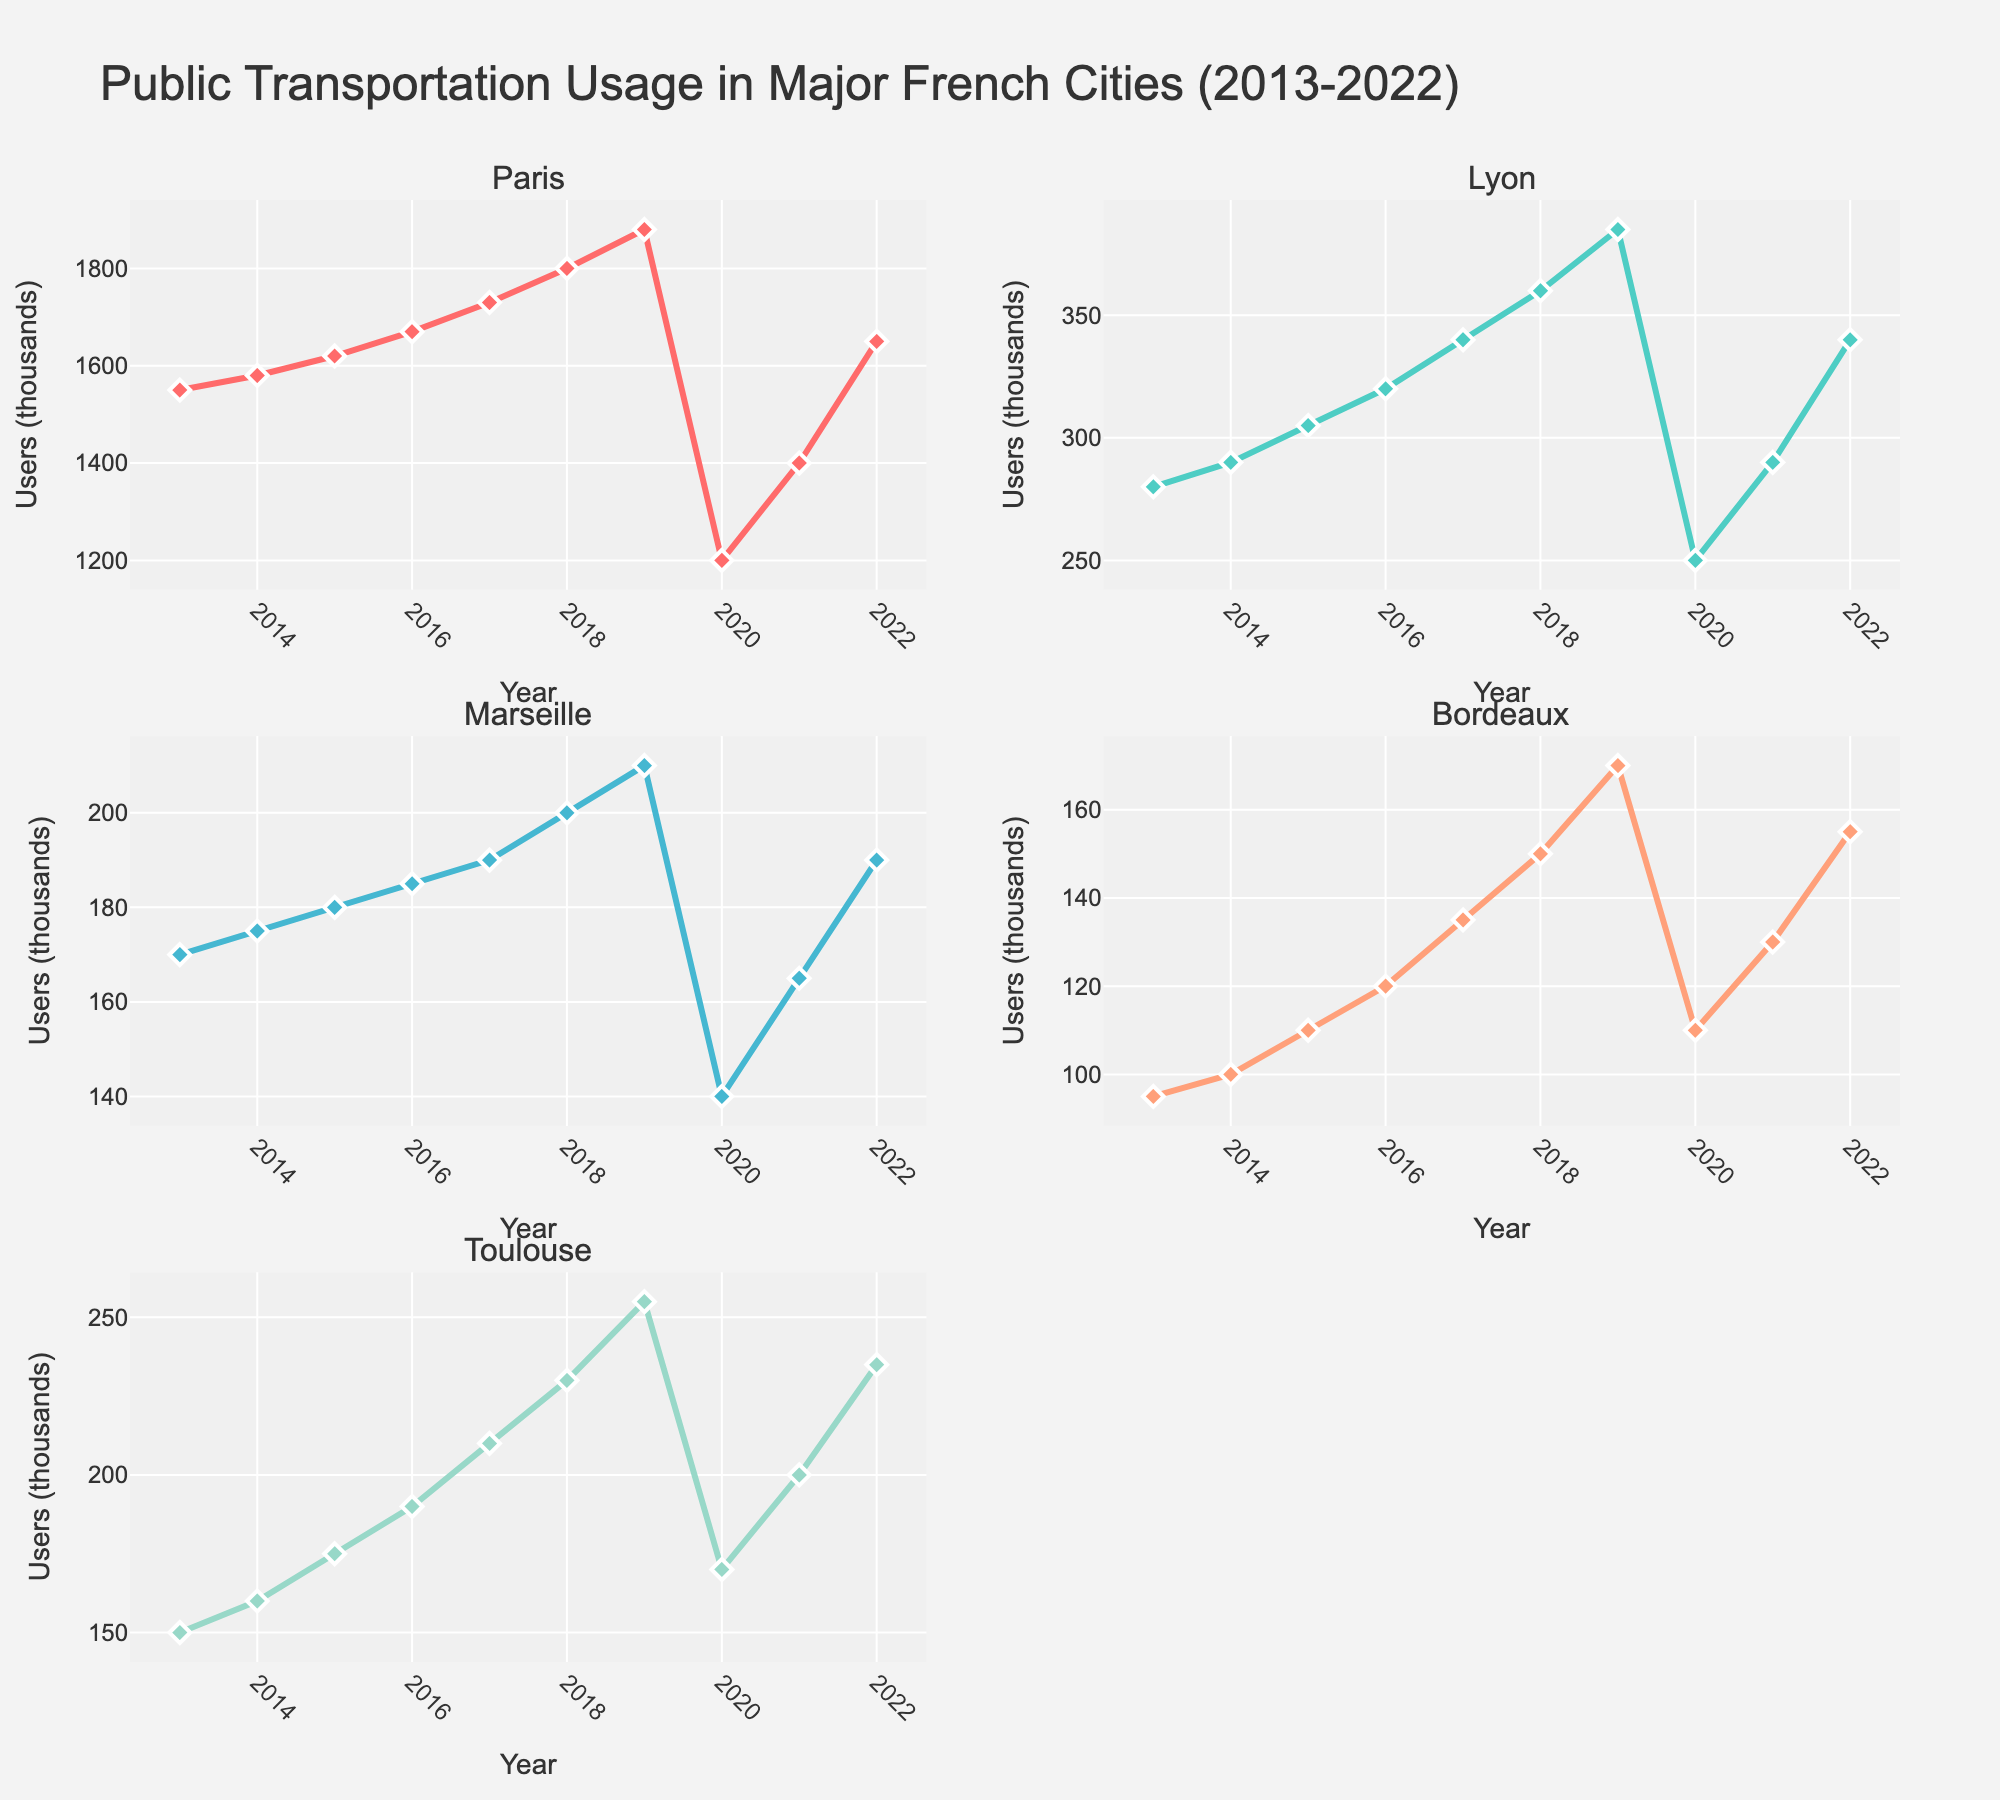What is the title of the figure? The title of the figure is usually located at the top of the plot, displaying an overall description of what the figure is about. In this case, it is "Public Transportation Usage in Major French Cities (2013-2022).”
Answer: Public Transportation Usage in Major French Cities (2013-2022) Which city had the highest public transportation usage in 2019? To find this, look at the subplot for each city and compare their values in 2019. The subplot for Paris has the highest value at 1880 thousand users.
Answer: Paris What is the trend of public transportation usage in Toulouse over the given years? Examine the subplot for Toulouse and observe the trajectory of the line from 2013 to 2022. Aside from a drop in 2020, the general trend is an increase.
Answer: Increasing In which year did Paris see the largest drop in public transportation usage? Observing the subplot for Paris, the year with the most significant drop is from 2019 to 2020, where usage fell from 1880 to 1200 thousand users.
Answer: 2020 How many users did Marseille have in 2016? Locate the subplot for Marseille and find the value corresponding to the year 2016, which is 185 thousand users.
Answer: 185 Compare the public transportation usage trends of Lyon and Marseille from 2013 to 2022. Look at both subplots for Lyon and Marseille. Lyon shows a consistent increase with a slight drop in 2020, while Marseille shows smaller but steady increments with a drop in 2020 as well.
Answer: Both increasing with a drop in 2020 What was the public transportation usage in Bordeaux in 2018? Examine the subplot for Bordeaux and find the value in 2018, which is 150 thousand users.
Answer: 150 Which city had the least public transportation usage in 2020? Check the values for each city in 2020 across the subplots. Marseille had the least usage at 140 thousand users.
Answer: Marseille How did public transportation usage change in Paris from 2019 to 2021? Observe the Paris subplot. The usage dropped from 1880 in 2019 to 1200 in 2020 and then increased to 1400 in 2021.
Answer: Decreased then increased What was the average number of public transportation users in Lyon over the decade? Add the annual values for Lyon (280, 290, 305, 320, 340, 360, 385, 250, 290, and 340) and divide by 10: (280 + 290 + 305 + 320 + 340 + 360 + 385 + 250 + 290 + 340) / 10 = 316
Answer: 316 